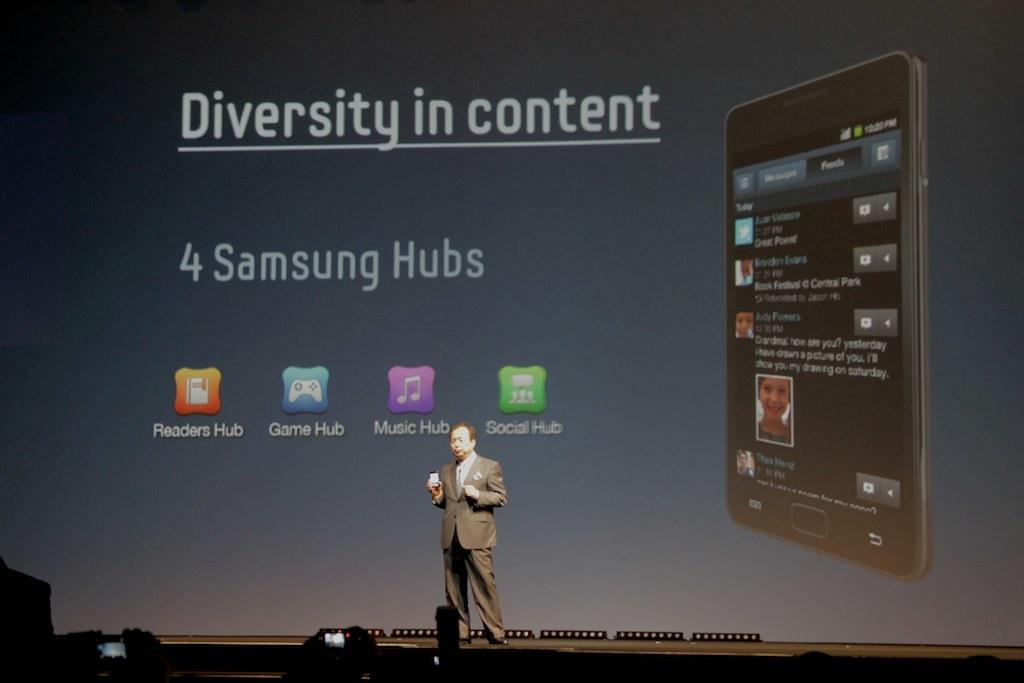<image>
Share a concise interpretation of the image provided. A presenter is talking about the diversity in content for a samsung phone. 